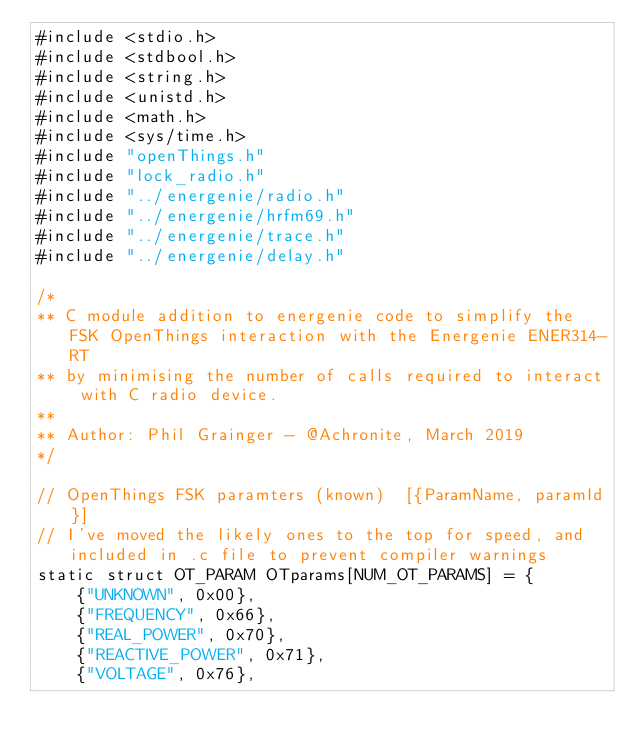Convert code to text. <code><loc_0><loc_0><loc_500><loc_500><_C_>#include <stdio.h>
#include <stdbool.h>
#include <string.h>
#include <unistd.h>
#include <math.h>
#include <sys/time.h>
#include "openThings.h"
#include "lock_radio.h"
#include "../energenie/radio.h"
#include "../energenie/hrfm69.h"
#include "../energenie/trace.h"
#include "../energenie/delay.h"

/*
** C module addition to energenie code to simplify the FSK OpenThings interaction with the Energenie ENER314-RT
** by minimising the number of calls required to interact with C radio device.
**
** Author: Phil Grainger - @Achronite, March 2019
*/

// OpenThings FSK paramters (known)  [{ParamName, paramId}]
// I've moved the likely ones to the top for speed, and included in .c file to prevent compiler warnings
static struct OT_PARAM OTparams[NUM_OT_PARAMS] = {
    {"UNKNOWN", 0x00},
    {"FREQUENCY", 0x66},
    {"REAL_POWER", 0x70},
    {"REACTIVE_POWER", 0x71},
    {"VOLTAGE", 0x76},</code> 